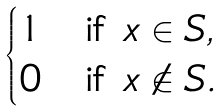Convert formula to latex. <formula><loc_0><loc_0><loc_500><loc_500>\begin{cases} 1 & \text {if $x \in S$} , \\ 0 & \text {if $x \notin S$} . \end{cases}</formula> 